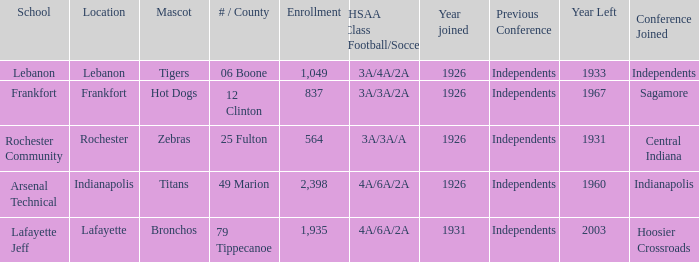What is the lowest enrollment that has Lafayette as the location? 1935.0. 